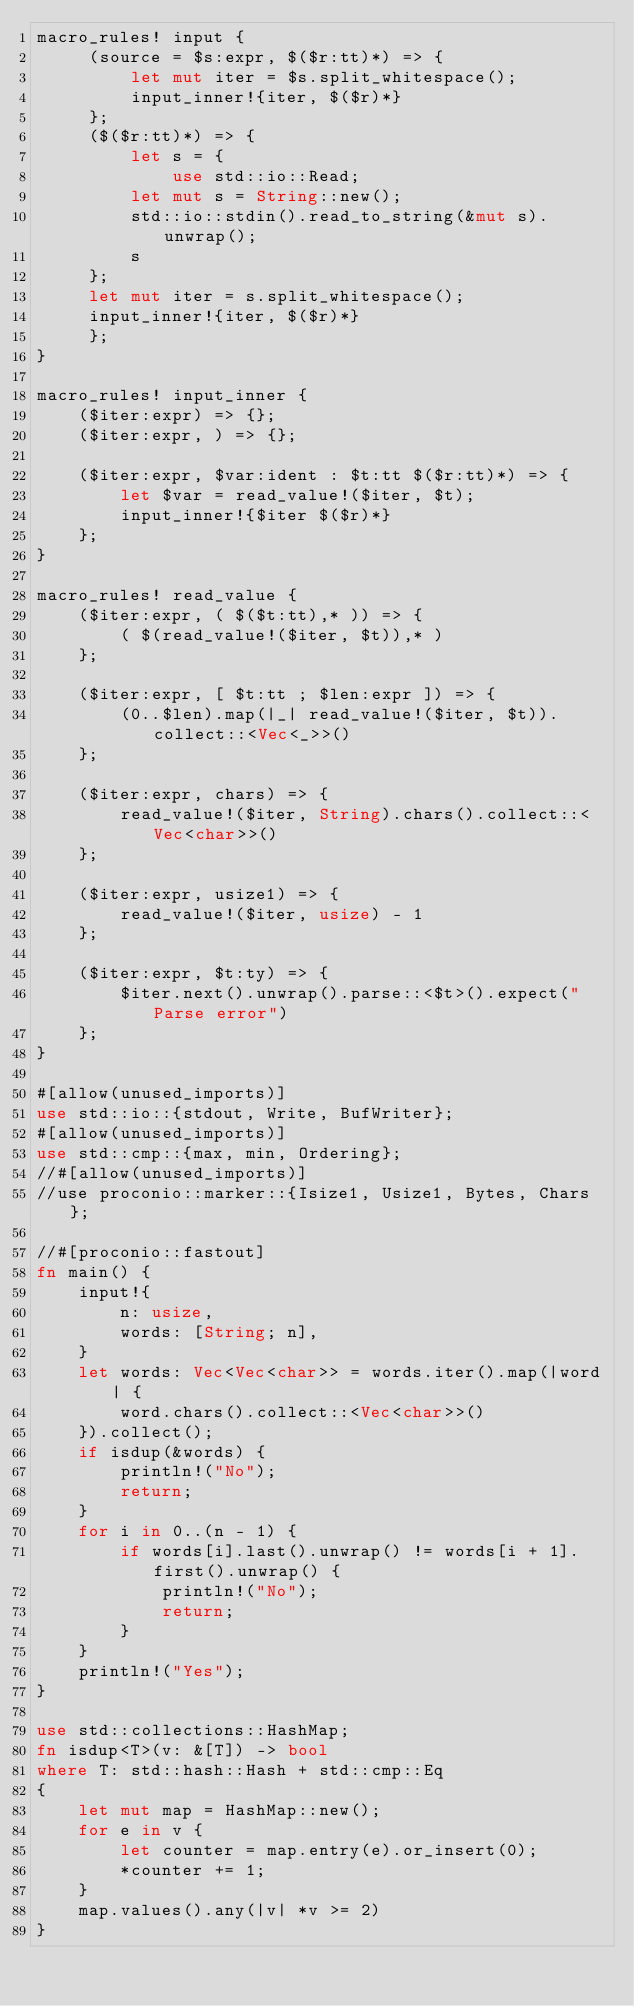Convert code to text. <code><loc_0><loc_0><loc_500><loc_500><_Rust_>macro_rules! input {
     (source = $s:expr, $($r:tt)*) => {
         let mut iter = $s.split_whitespace();
         input_inner!{iter, $($r)*}
     };
     ($($r:tt)*) => {
         let s = {
             use std::io::Read;
         let mut s = String::new();
         std::io::stdin().read_to_string(&mut s).unwrap();
         s
     };
     let mut iter = s.split_whitespace();
     input_inner!{iter, $($r)*}
     };
}
     
macro_rules! input_inner {
    ($iter:expr) => {};
    ($iter:expr, ) => {};
 
    ($iter:expr, $var:ident : $t:tt $($r:tt)*) => {
        let $var = read_value!($iter, $t);
        input_inner!{$iter $($r)*}
    };
}
 
macro_rules! read_value {
    ($iter:expr, ( $($t:tt),* )) => {
        ( $(read_value!($iter, $t)),* )
    };
 
    ($iter:expr, [ $t:tt ; $len:expr ]) => {
        (0..$len).map(|_| read_value!($iter, $t)).collect::<Vec<_>>()
    };
 
    ($iter:expr, chars) => {
        read_value!($iter, String).chars().collect::<Vec<char>>()
    };
 
    ($iter:expr, usize1) => {
        read_value!($iter, usize) - 1
    };
 
    ($iter:expr, $t:ty) => {
        $iter.next().unwrap().parse::<$t>().expect("Parse error")
    };
}

#[allow(unused_imports)]
use std::io::{stdout, Write, BufWriter};
#[allow(unused_imports)]
use std::cmp::{max, min, Ordering};
//#[allow(unused_imports)]
//use proconio::marker::{Isize1, Usize1, Bytes, Chars};

//#[proconio::fastout]
fn main() {
    input!{
        n: usize,
        words: [String; n],
    }
    let words: Vec<Vec<char>> = words.iter().map(|word| {
        word.chars().collect::<Vec<char>>()
    }).collect();
    if isdup(&words) {
        println!("No");
        return;
    }
    for i in 0..(n - 1) {
        if words[i].last().unwrap() != words[i + 1].first().unwrap() {
            println!("No");
            return;
        }
    }
    println!("Yes");
}

use std::collections::HashMap;
fn isdup<T>(v: &[T]) -> bool
where T: std::hash::Hash + std::cmp::Eq
{
    let mut map = HashMap::new();
    for e in v {
        let counter = map.entry(e).or_insert(0);
        *counter += 1;
    }
    map.values().any(|v| *v >= 2)
}
</code> 